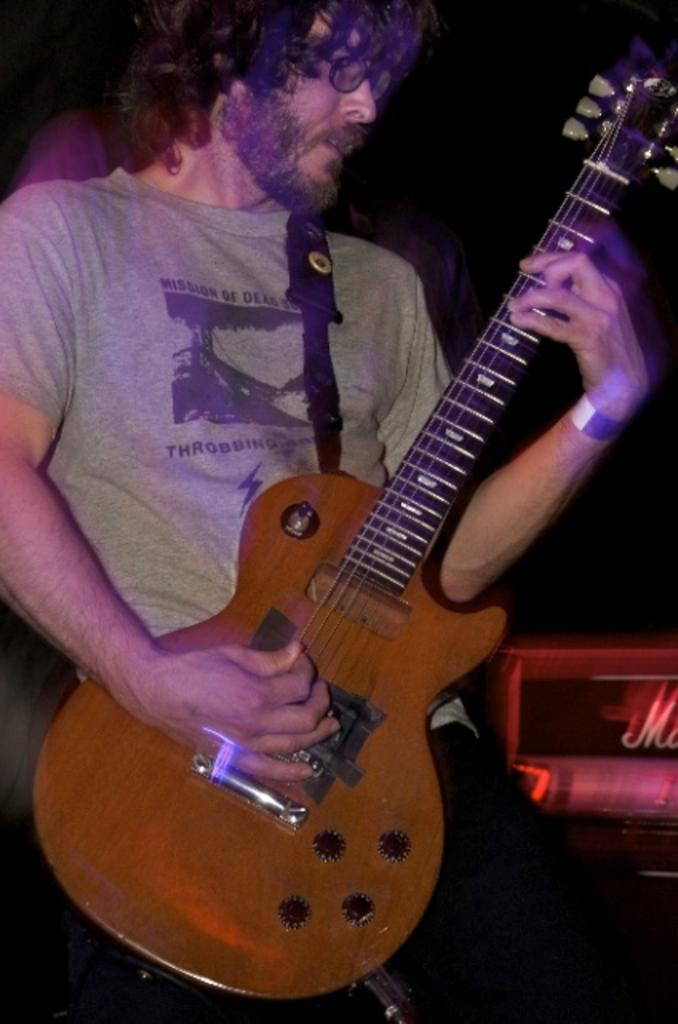What is the main subject of the image? There is a man in the image. What is the man holding in the image? The man is holding a guitar. What is the man doing with the guitar? The man is playing the guitar. What type of bead is the man using to play the guitar in the image? There is no bead present in the image; the man is playing the guitar with his hands. 